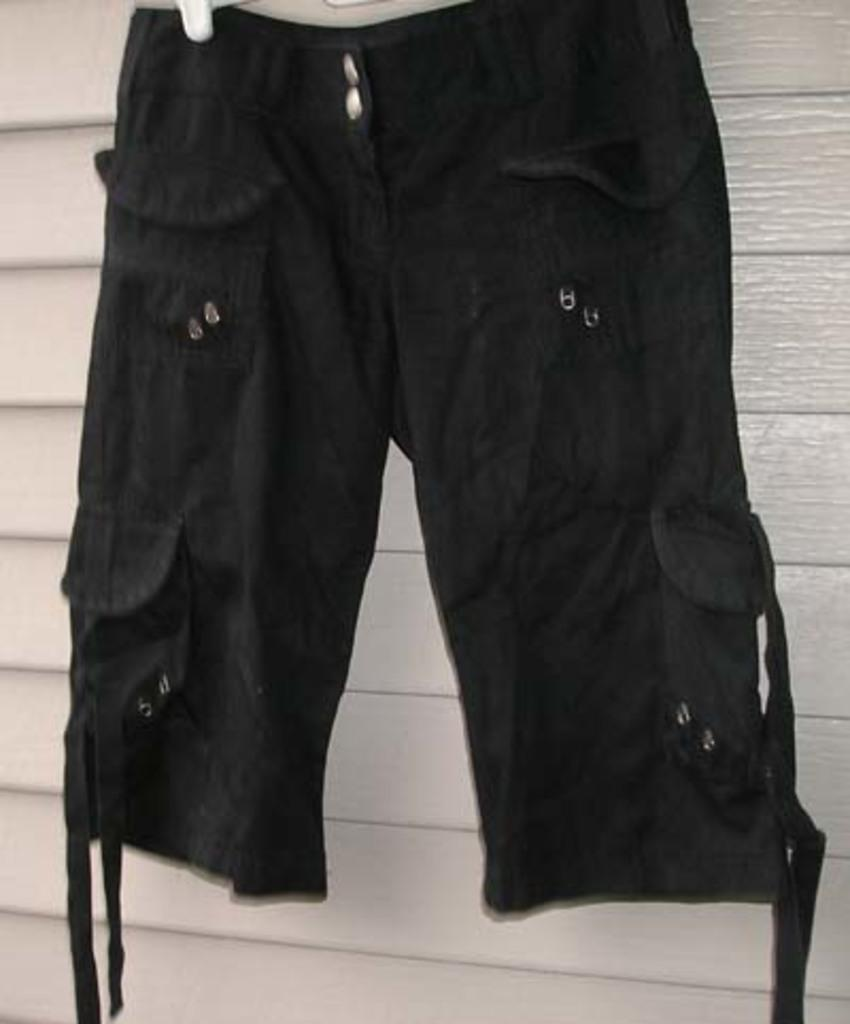What type of clothing item is visible in the image? There is a pair of shorts in the image. How many geese are standing on the hole in the image? There are no geese or holes present in the image; it only features a pair of shorts. 